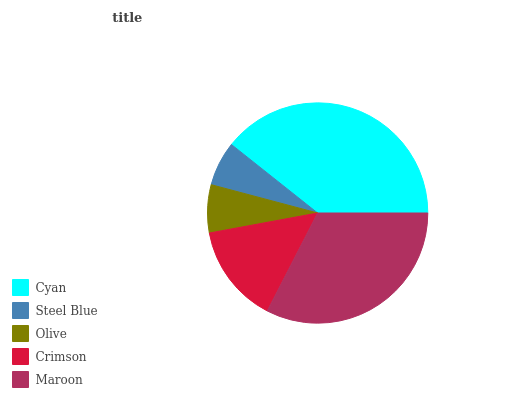Is Steel Blue the minimum?
Answer yes or no. Yes. Is Cyan the maximum?
Answer yes or no. Yes. Is Olive the minimum?
Answer yes or no. No. Is Olive the maximum?
Answer yes or no. No. Is Olive greater than Steel Blue?
Answer yes or no. Yes. Is Steel Blue less than Olive?
Answer yes or no. Yes. Is Steel Blue greater than Olive?
Answer yes or no. No. Is Olive less than Steel Blue?
Answer yes or no. No. Is Crimson the high median?
Answer yes or no. Yes. Is Crimson the low median?
Answer yes or no. Yes. Is Maroon the high median?
Answer yes or no. No. Is Cyan the low median?
Answer yes or no. No. 